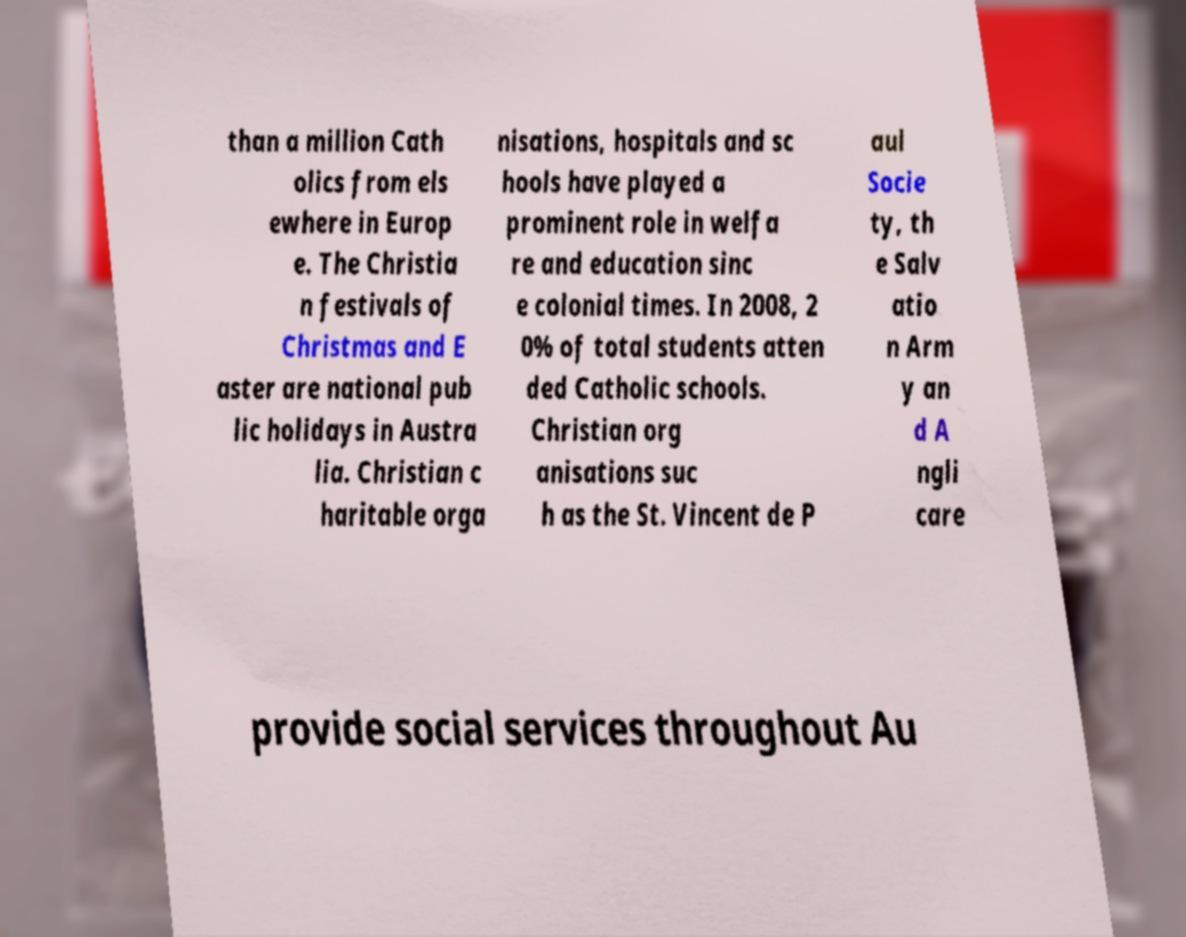There's text embedded in this image that I need extracted. Can you transcribe it verbatim? than a million Cath olics from els ewhere in Europ e. The Christia n festivals of Christmas and E aster are national pub lic holidays in Austra lia. Christian c haritable orga nisations, hospitals and sc hools have played a prominent role in welfa re and education sinc e colonial times. In 2008, 2 0% of total students atten ded Catholic schools. Christian org anisations suc h as the St. Vincent de P aul Socie ty, th e Salv atio n Arm y an d A ngli care provide social services throughout Au 